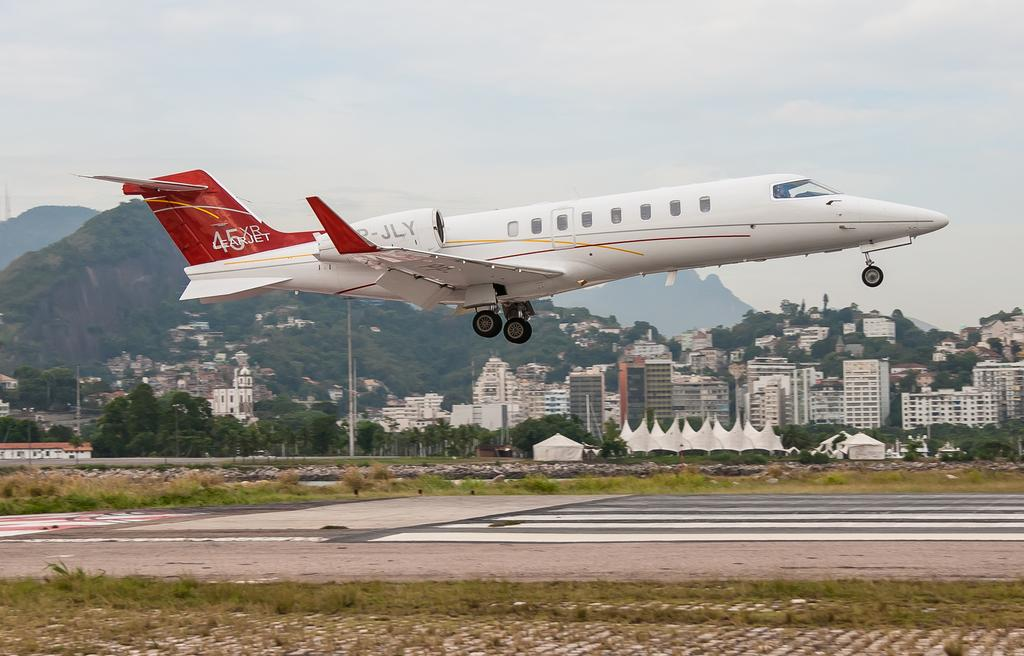What is the main subject of the image? The main subject of the image is an airplane flying in the sky. Where is the airplane located in the image? The airplane is in the center of the image. What can be seen in the background of the image? There are buildings, trees, and mountains in the background of the image. What is the condition of the sky in the image? The sky is cloudy in the image. How many spaceships can be seen in the image? There are no spaceships present in the image; it features an airplane flying in the sky. What type of floor is visible beneath the airplane in the image? There is no floor visible in the image, as the airplane is flying in the sky. 